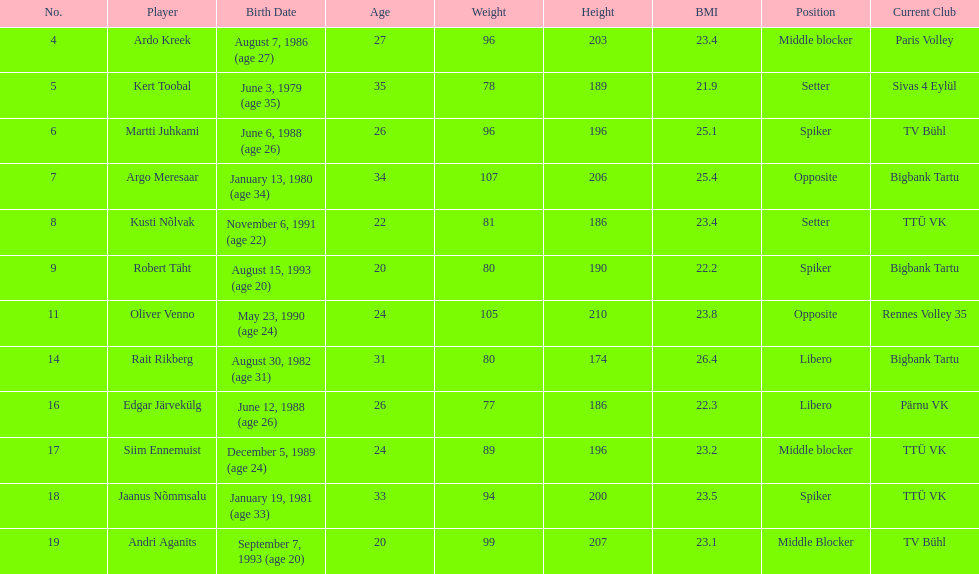Who is not younger than 25 years old? Ardo Kreek, Kert Toobal, Martti Juhkami, Argo Meresaar, Rait Rikberg, Edgar Järvekülg, Jaanus Nõmmsalu. 